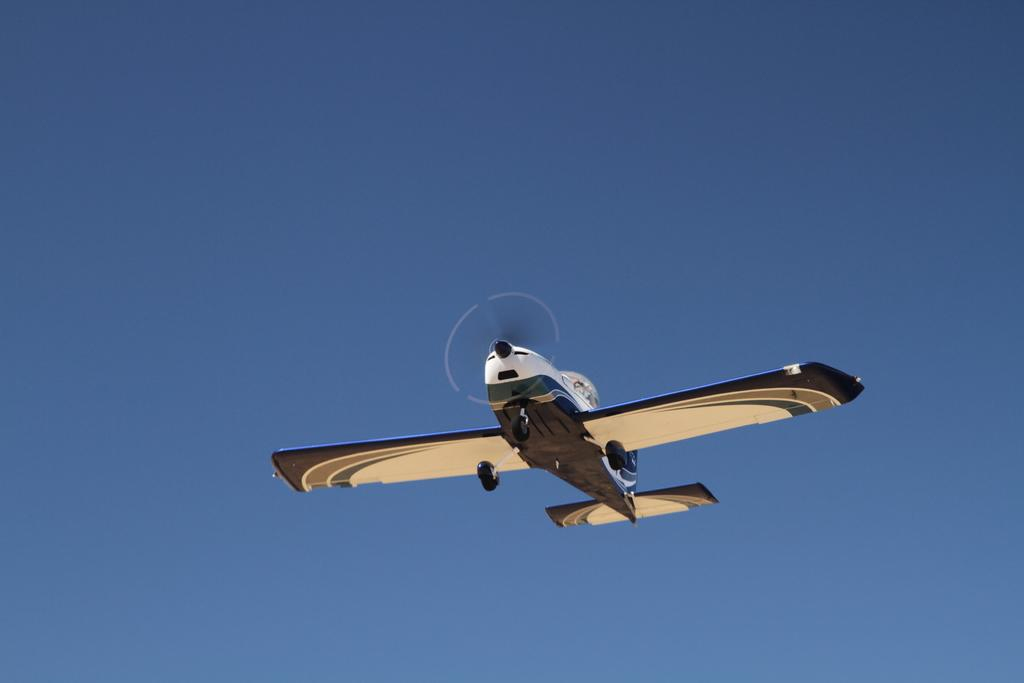What is the main subject of the image? The main subject of the image is an airplane. Can you describe the position of the airplane in the image? The airplane is in the air in the image. What can be seen in the background of the image? The sky is visible in the background of the image. Can you see a nest in the image? There is no nest present in the image. 